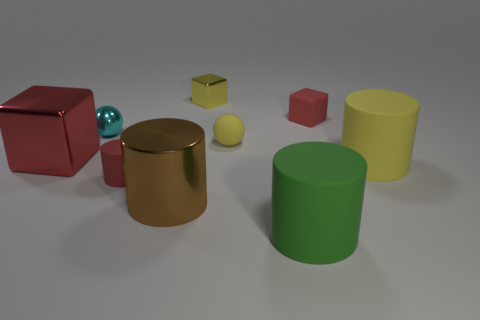Is the number of yellow matte cylinders greater than the number of tiny gray matte spheres?
Offer a terse response. Yes. There is a matte thing to the right of the small rubber thing right of the green cylinder; what is its size?
Your answer should be very brief. Large. There is a tiny rubber thing that is the same shape as the red metal object; what color is it?
Your response must be concise. Red. How big is the green cylinder?
Your response must be concise. Large. How many blocks are red metal objects or big brown things?
Ensure brevity in your answer.  1. The other metal thing that is the same shape as the yellow metal thing is what size?
Provide a short and direct response. Large. How many rubber cylinders are there?
Offer a very short reply. 3. There is a large red object; does it have the same shape as the yellow rubber object to the left of the green rubber cylinder?
Offer a very short reply. No. There is a red matte thing in front of the large yellow rubber thing; what size is it?
Offer a very short reply. Small. What is the material of the big brown cylinder?
Give a very brief answer. Metal. 